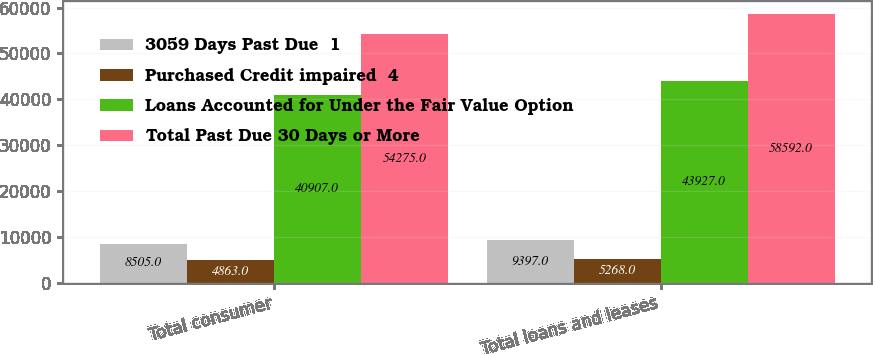Convert chart to OTSL. <chart><loc_0><loc_0><loc_500><loc_500><stacked_bar_chart><ecel><fcel>Total consumer<fcel>Total loans and leases<nl><fcel>3059 Days Past Due  1<fcel>8505<fcel>9397<nl><fcel>Purchased Credit impaired  4<fcel>4863<fcel>5268<nl><fcel>Loans Accounted for Under the Fair Value Option<fcel>40907<fcel>43927<nl><fcel>Total Past Due 30 Days or More<fcel>54275<fcel>58592<nl></chart> 